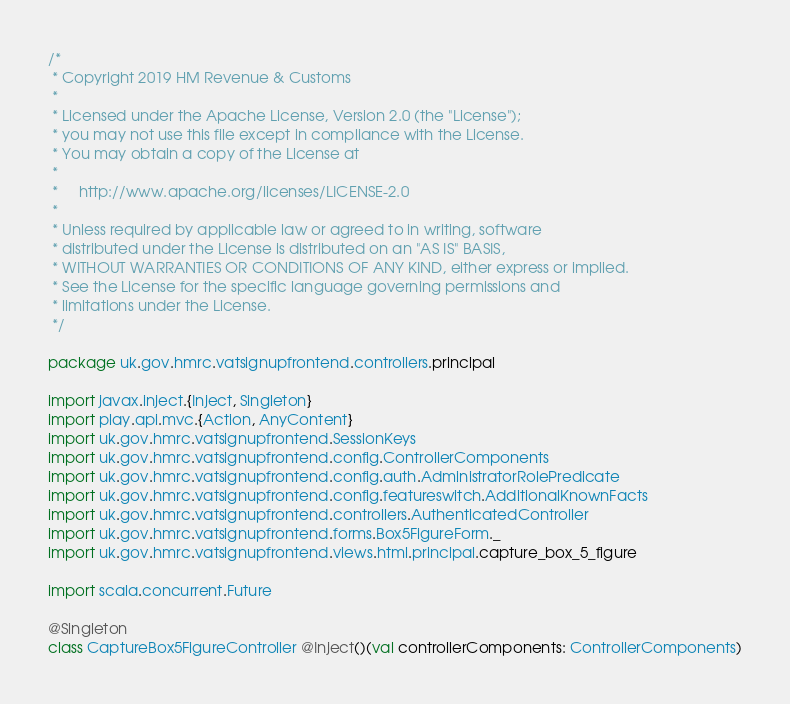Convert code to text. <code><loc_0><loc_0><loc_500><loc_500><_Scala_>/*
 * Copyright 2019 HM Revenue & Customs
 *
 * Licensed under the Apache License, Version 2.0 (the "License");
 * you may not use this file except in compliance with the License.
 * You may obtain a copy of the License at
 *
 *     http://www.apache.org/licenses/LICENSE-2.0
 *
 * Unless required by applicable law or agreed to in writing, software
 * distributed under the License is distributed on an "AS IS" BASIS,
 * WITHOUT WARRANTIES OR CONDITIONS OF ANY KIND, either express or implied.
 * See the License for the specific language governing permissions and
 * limitations under the License.
 */

package uk.gov.hmrc.vatsignupfrontend.controllers.principal

import javax.inject.{Inject, Singleton}
import play.api.mvc.{Action, AnyContent}
import uk.gov.hmrc.vatsignupfrontend.SessionKeys
import uk.gov.hmrc.vatsignupfrontend.config.ControllerComponents
import uk.gov.hmrc.vatsignupfrontend.config.auth.AdministratorRolePredicate
import uk.gov.hmrc.vatsignupfrontend.config.featureswitch.AdditionalKnownFacts
import uk.gov.hmrc.vatsignupfrontend.controllers.AuthenticatedController
import uk.gov.hmrc.vatsignupfrontend.forms.Box5FigureForm._
import uk.gov.hmrc.vatsignupfrontend.views.html.principal.capture_box_5_figure

import scala.concurrent.Future

@Singleton
class CaptureBox5FigureController @Inject()(val controllerComponents: ControllerComponents)
</code> 